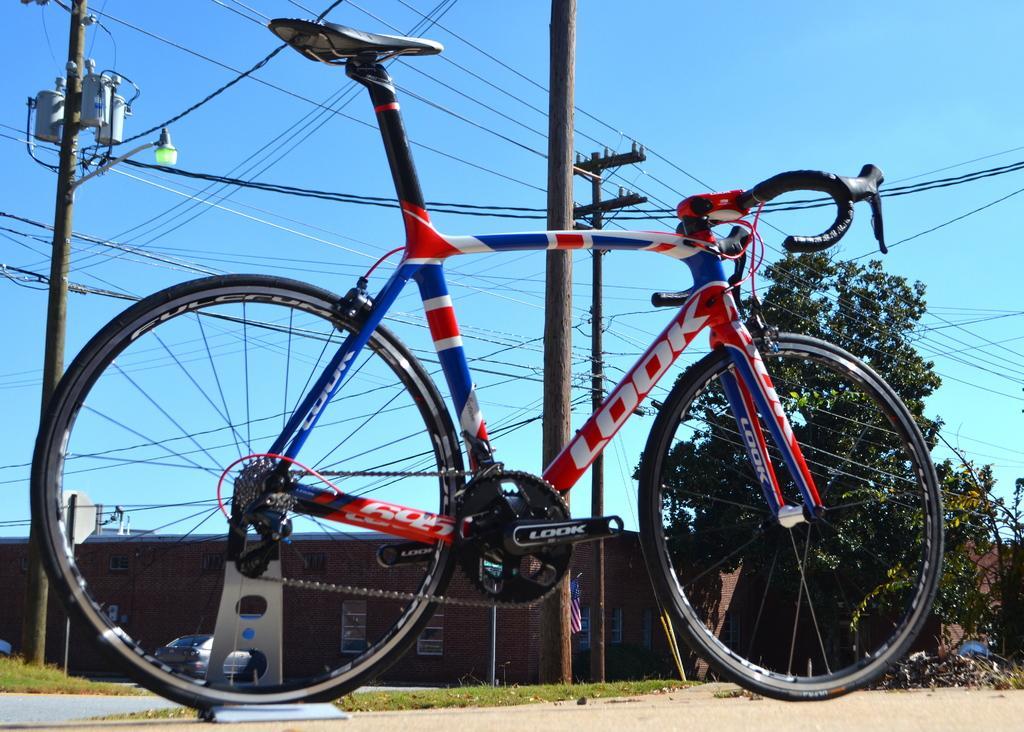Please provide a concise description of this image. In this image we can see a cycle. In the back we can see electric poles with wires. In the background there is car. Also there is a building with windows. And there is a tree. And there is sky. 